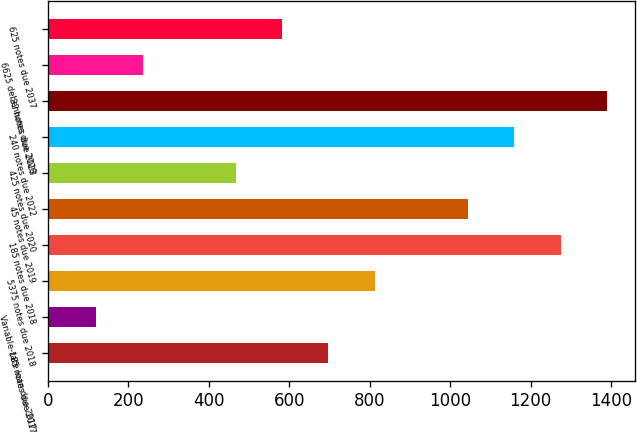Convert chart to OTSL. <chart><loc_0><loc_0><loc_500><loc_500><bar_chart><fcel>185 notes due 2017<fcel>Variable-rate loan due 2017<fcel>5375 notes due 2018<fcel>185 notes due 2018<fcel>45 notes due 2019<fcel>425 notes due 2020<fcel>240 notes due 2022<fcel>32 notes due 2023<fcel>6625 debentures due 2028<fcel>625 notes due 2037<nl><fcel>697.5<fcel>120<fcel>813<fcel>1275<fcel>1044<fcel>466.5<fcel>1159.5<fcel>1390.5<fcel>235.5<fcel>582<nl></chart> 